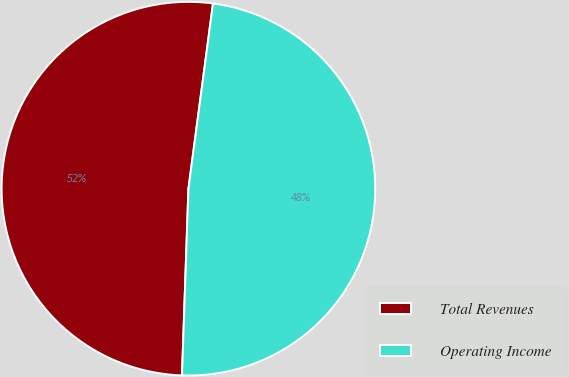Convert chart. <chart><loc_0><loc_0><loc_500><loc_500><pie_chart><fcel>Total Revenues<fcel>Operating Income<nl><fcel>51.55%<fcel>48.45%<nl></chart> 